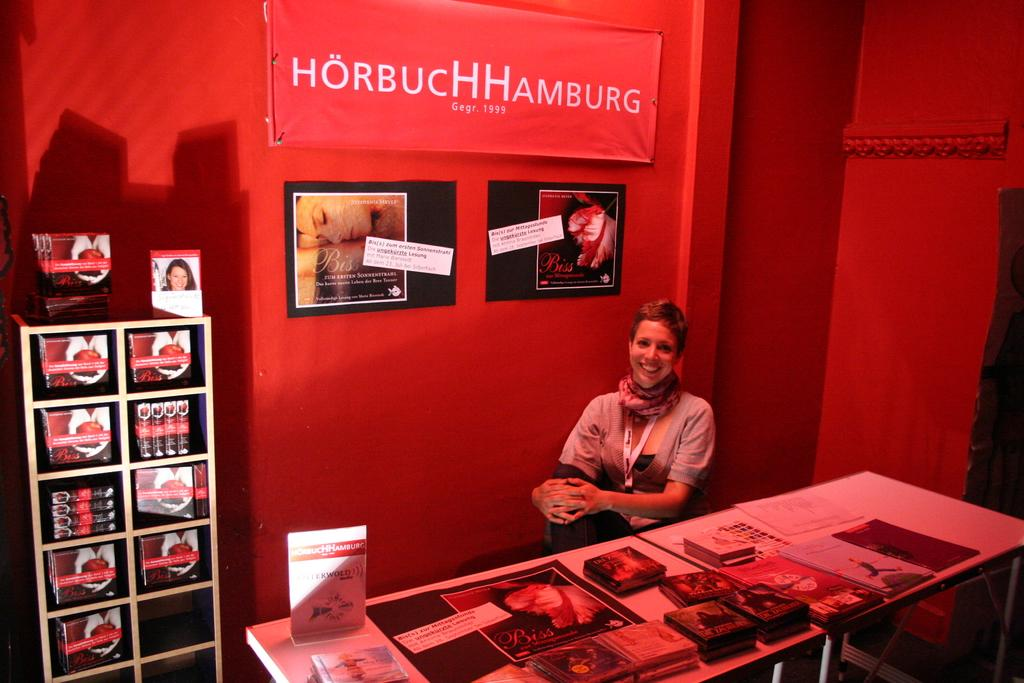<image>
Give a short and clear explanation of the subsequent image. A girl sits at a table at a booth for Horbuch Hamburg. 